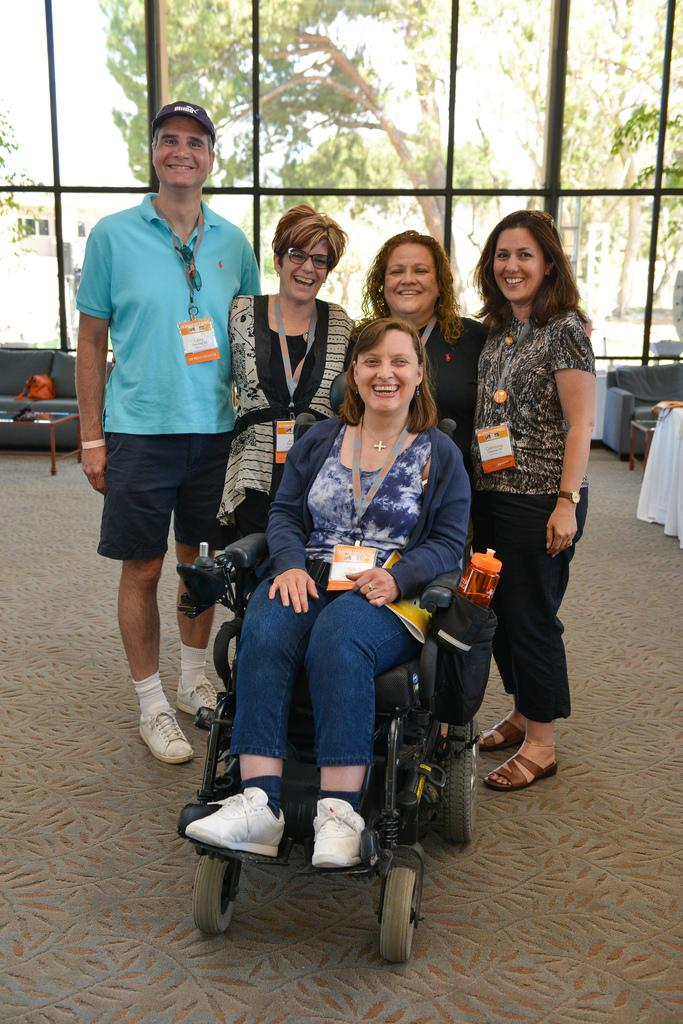What type of vegetation can be seen in the image? There are trees in the image. What architectural feature is present in the image? There is a window in the image. Who or what is visible inside the window? There are people in the image. What type of furniture is visible in the image? There are sofas visible in the image. What is the distribution of the facts about the image? The facts about the image are not a distribution; they are a list of specific details about the image. What cast of characters is present in the image? There is no cast of characters in the image; it is a photograph or illustration of real-life subjects. 